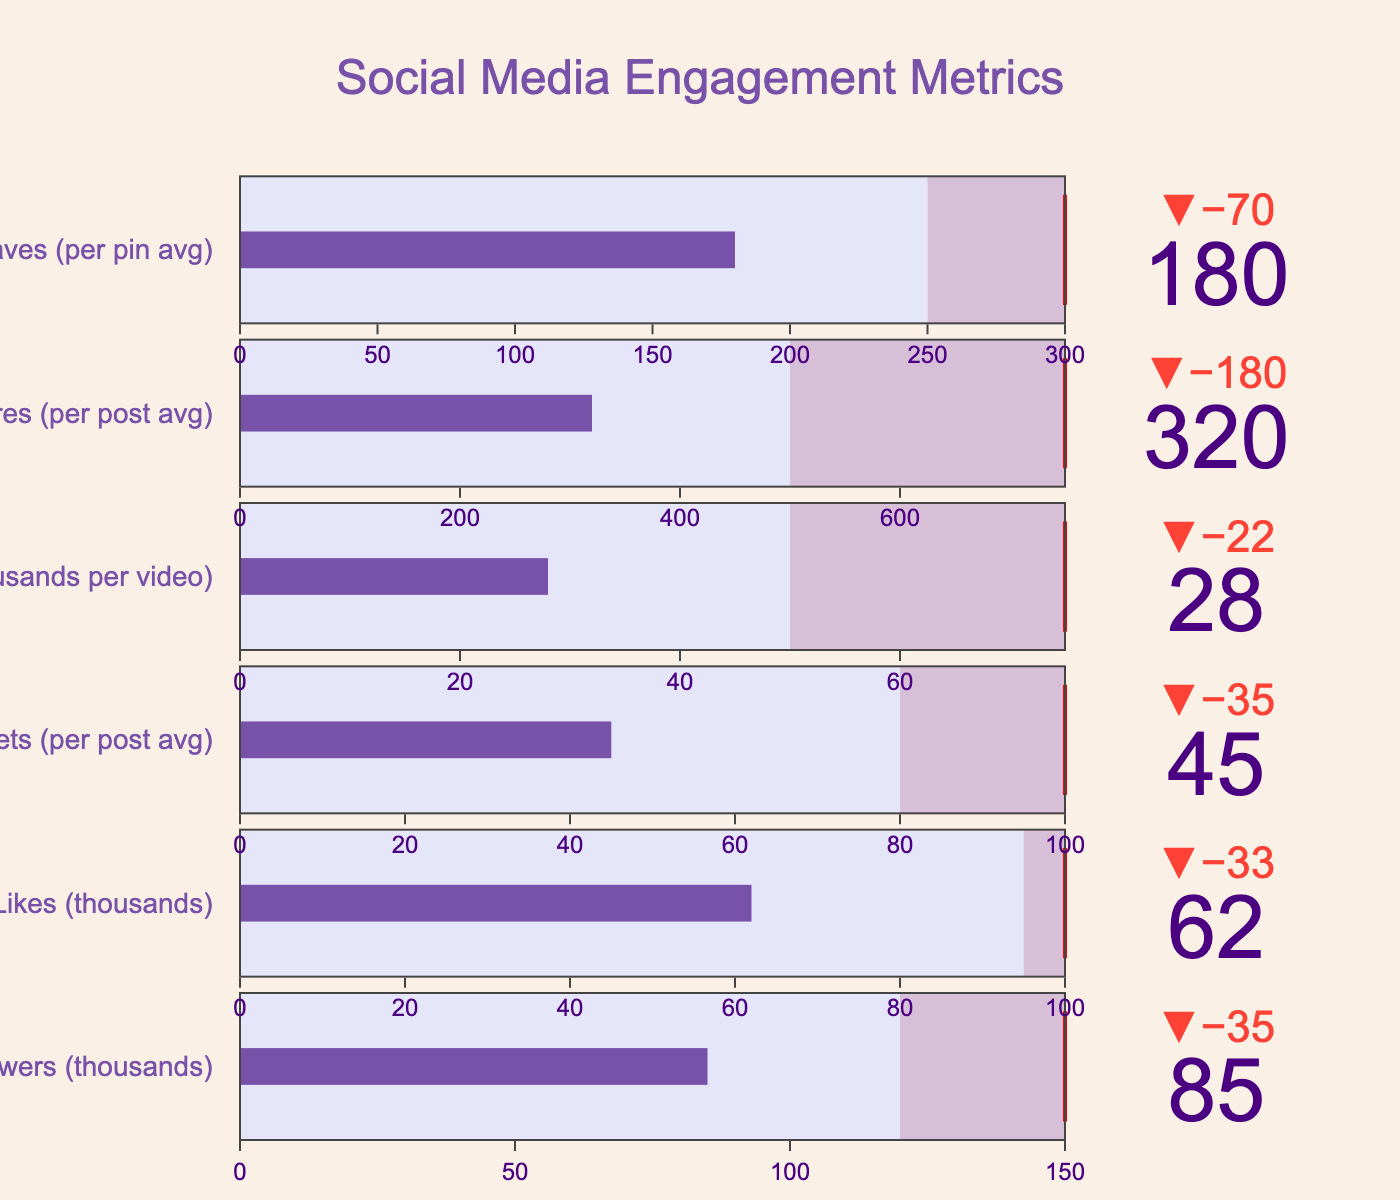What is the title of the figure? The title of the figure is displayed prominently at the top of the chart. It summarizes the content and purpose of the chart.
Answer: Social Media Engagement Metrics How many different social media metrics are tracked in the figure? You can count the number of bullet gauges along the y-axis; each represents a different metric.
Answer: 6 Which social media metric has the lowest actual value? Observe the actual value bars for each metric and compare them.
Answer: YouTube Views What is the difference between the actual and comparative values for Instagram Followers? Subtract the actual value from the comparative value for the Instagram Followers metric.
Answer: 35 How do the Instagram Followers compare to the Target? Notice the length of the actual value bar for Instagram Followers and compare it to the target marker on the gauge.
Answer: Significantly lower Which social media metric comes closest to reaching its target? Compare the positions of the actual value bars relative to their target thresholds on each gauge.
Answer: Pinterest Saves What provides a greater challenge: increasing Twitter Retweets to its target or increasing TikTok Shares to its target? Compare the differences between actual values and their respective target values for both metrics.
Answer: TikTok Shares Which social media metric shows the largest disparity between its actual value and its target? Calculate and compare the differences for all metrics between their actual values and targets.
Answer: TikTok Shares Among Instagram Followers, Facebook Page Likes, and Twitter Retweets, which metric is closer to its comparative value but farthest from the target? Compare the relative positions of actual values to comparative and target values for these metrics.
Answer: Facebook Page Likes 